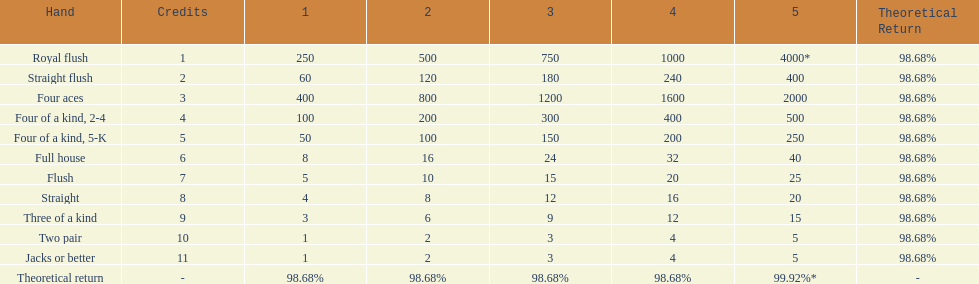I'm looking to parse the entire table for insights. Could you assist me with that? {'header': ['Hand', 'Credits', '1', '2', '3', '4', '5', 'Theoretical Return'], 'rows': [['Royal flush', '1', '250', '500', '750', '1000', '4000*', '98.68%'], ['Straight flush', '2', '60', '120', '180', '240', '400', '98.68%'], ['Four aces', '3', '400', '800', '1200', '1600', '2000', '98.68%'], ['Four of a kind, 2-4', '4', '100', '200', '300', '400', '500', '98.68%'], ['Four of a kind, 5-K', '5', '50', '100', '150', '200', '250', '98.68%'], ['Full house', '6', '8', '16', '24', '32', '40', '98.68%'], ['Flush', '7', '5', '10', '15', '20', '25', '98.68%'], ['Straight', '8', '4', '8', '12', '16', '20', '98.68%'], ['Three of a kind', '9', '3', '6', '9', '12', '15', '98.68%'], ['Two pair', '10', '1', '2', '3', '4', '5', '98.68%'], ['Jacks or better', '11', '1', '2', '3', '4', '5', '98.68%'], ['Theoretical return', '-', '98.68%', '98.68%', '98.68%', '98.68%', '99.92%*', '-']]} The number of credits returned for a one credit bet on a royal flush are. 250. 